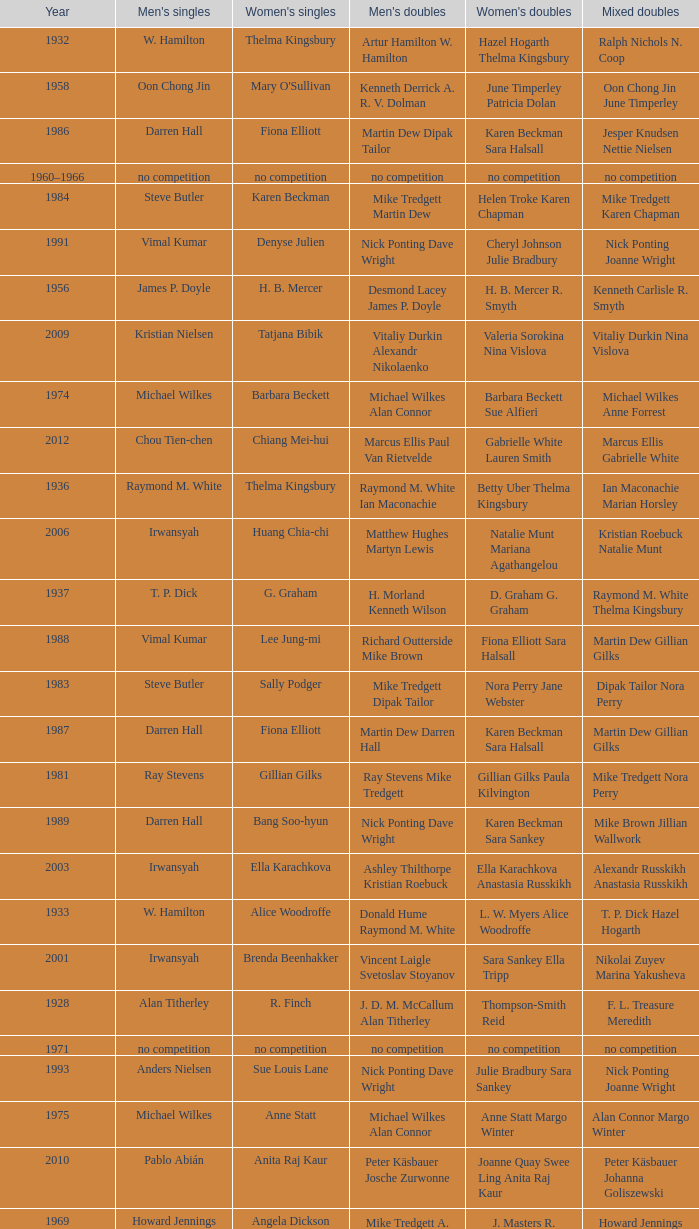Who won the Men's singles in the year that Ian Maconachie Marian Horsley won the Mixed doubles? Raymond M. White. 